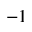Convert formula to latex. <formula><loc_0><loc_0><loc_500><loc_500>^ { - 1 }</formula> 